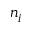<formula> <loc_0><loc_0><loc_500><loc_500>n _ { i }</formula> 